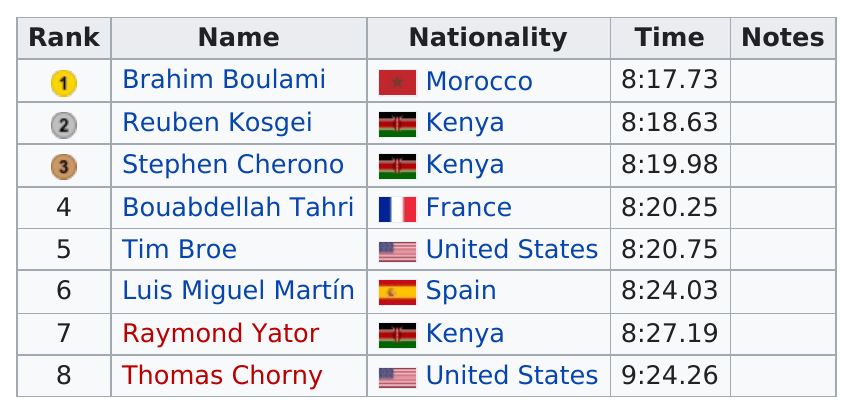Point out several critical features in this image. Kenya won a total of two medals in the competition. The average time of medal winners is approximately 8 hours and 18 minutes and 78 seconds. The last competitor to finish the race was Thomas Chorny. Reuben Kosegi and Stephen Cherono are both from Kenya. The nationality of the first ranked competitor is Morocco. 